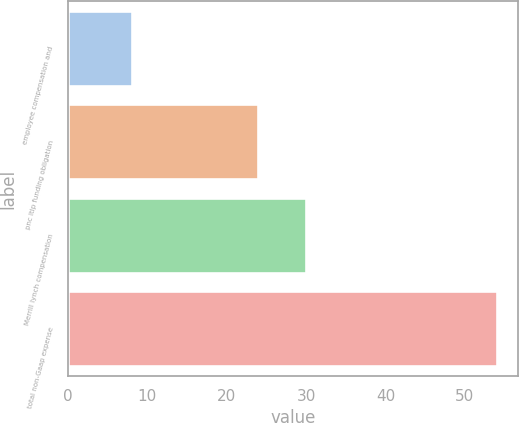<chart> <loc_0><loc_0><loc_500><loc_500><bar_chart><fcel>employee compensation and<fcel>pnc ltip funding obligation<fcel>Merrill lynch compensation<fcel>total non-Gaap expense<nl><fcel>8.1<fcel>24<fcel>30<fcel>54<nl></chart> 